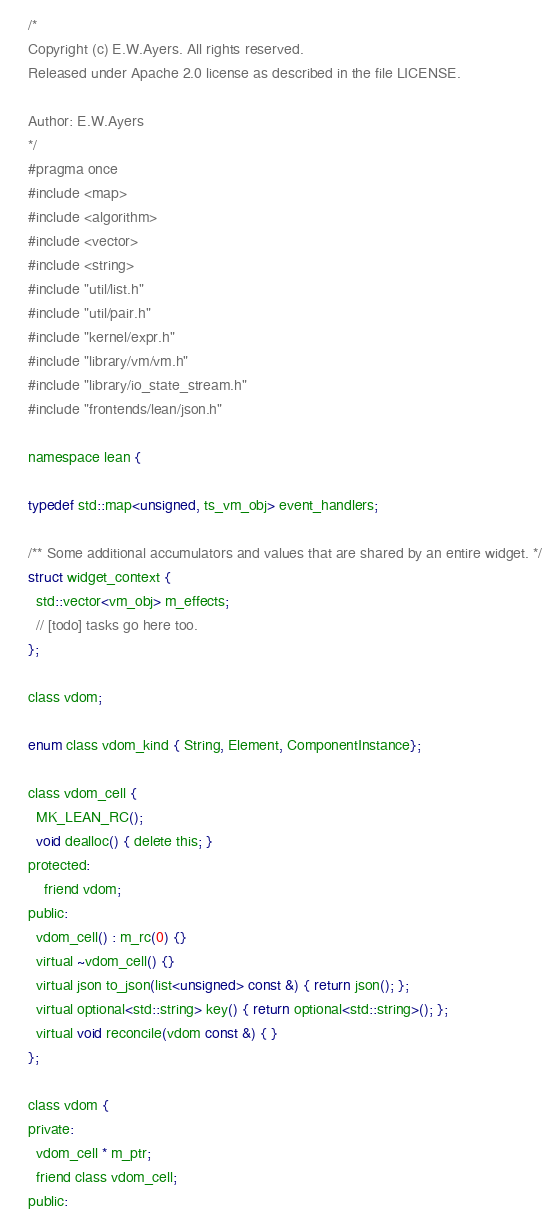<code> <loc_0><loc_0><loc_500><loc_500><_C_>/*
Copyright (c) E.W.Ayers. All rights reserved.
Released under Apache 2.0 license as described in the file LICENSE.

Author: E.W.Ayers
*/
#pragma once
#include <map>
#include <algorithm>
#include <vector>
#include <string>
#include "util/list.h"
#include "util/pair.h"
#include "kernel/expr.h"
#include "library/vm/vm.h"
#include "library/io_state_stream.h"
#include "frontends/lean/json.h"

namespace lean {

typedef std::map<unsigned, ts_vm_obj> event_handlers;

/** Some additional accumulators and values that are shared by an entire widget. */
struct widget_context {
  std::vector<vm_obj> m_effects;
  // [todo] tasks go here too.
};

class vdom;

enum class vdom_kind { String, Element, ComponentInstance};

class vdom_cell {
  MK_LEAN_RC();
  void dealloc() { delete this; }
protected:
    friend vdom;
public:
  vdom_cell() : m_rc(0) {}
  virtual ~vdom_cell() {}
  virtual json to_json(list<unsigned> const &) { return json(); };
  virtual optional<std::string> key() { return optional<std::string>(); };
  virtual void reconcile(vdom const &) { }
};

class vdom {
private:
  vdom_cell * m_ptr;
  friend class vdom_cell;
public:</code> 